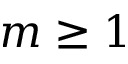Convert formula to latex. <formula><loc_0><loc_0><loc_500><loc_500>m \geq 1</formula> 